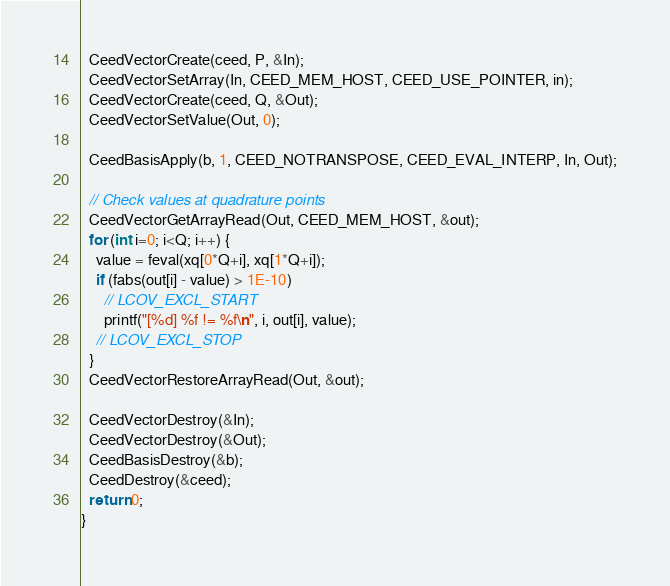<code> <loc_0><loc_0><loc_500><loc_500><_C_>
  CeedVectorCreate(ceed, P, &In);
  CeedVectorSetArray(In, CEED_MEM_HOST, CEED_USE_POINTER, in);
  CeedVectorCreate(ceed, Q, &Out);
  CeedVectorSetValue(Out, 0);

  CeedBasisApply(b, 1, CEED_NOTRANSPOSE, CEED_EVAL_INTERP, In, Out);

  // Check values at quadrature points
  CeedVectorGetArrayRead(Out, CEED_MEM_HOST, &out);
  for (int i=0; i<Q; i++) {
    value = feval(xq[0*Q+i], xq[1*Q+i]);
    if (fabs(out[i] - value) > 1E-10)
      // LCOV_EXCL_START
      printf("[%d] %f != %f\n", i, out[i], value);
    // LCOV_EXCL_STOP
  }
  CeedVectorRestoreArrayRead(Out, &out);

  CeedVectorDestroy(&In);
  CeedVectorDestroy(&Out);
  CeedBasisDestroy(&b);
  CeedDestroy(&ceed);
  return 0;
}
</code> 